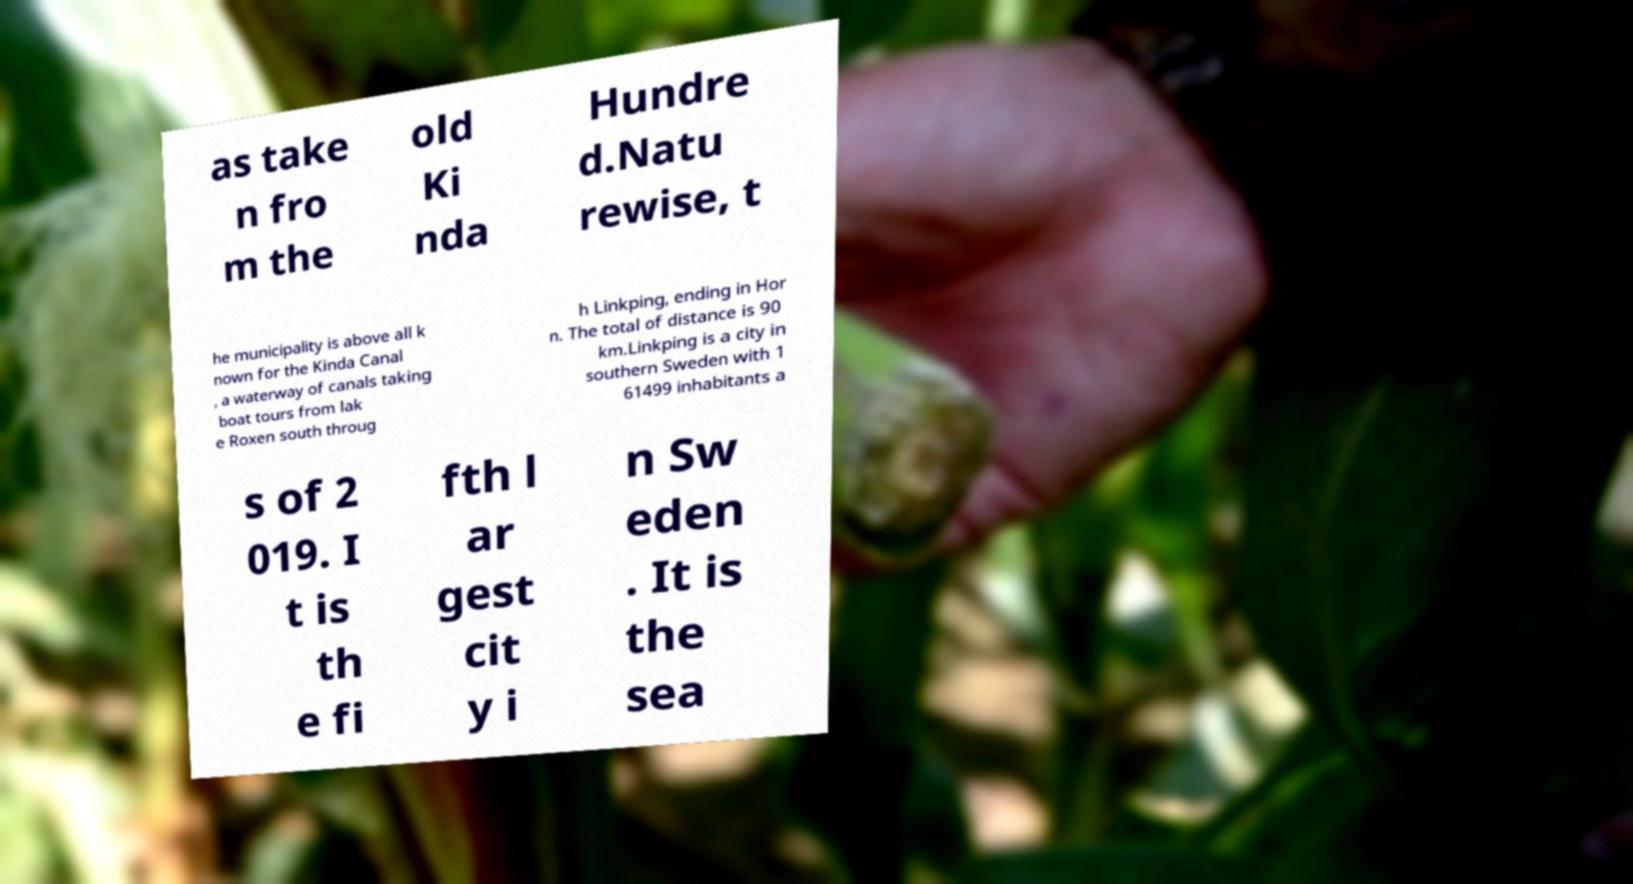What messages or text are displayed in this image? I need them in a readable, typed format. as take n fro m the old Ki nda Hundre d.Natu rewise, t he municipality is above all k nown for the Kinda Canal , a waterway of canals taking boat tours from lak e Roxen south throug h Linkping, ending in Hor n. The total of distance is 90 km.Linkping is a city in southern Sweden with 1 61499 inhabitants a s of 2 019. I t is th e fi fth l ar gest cit y i n Sw eden . It is the sea 